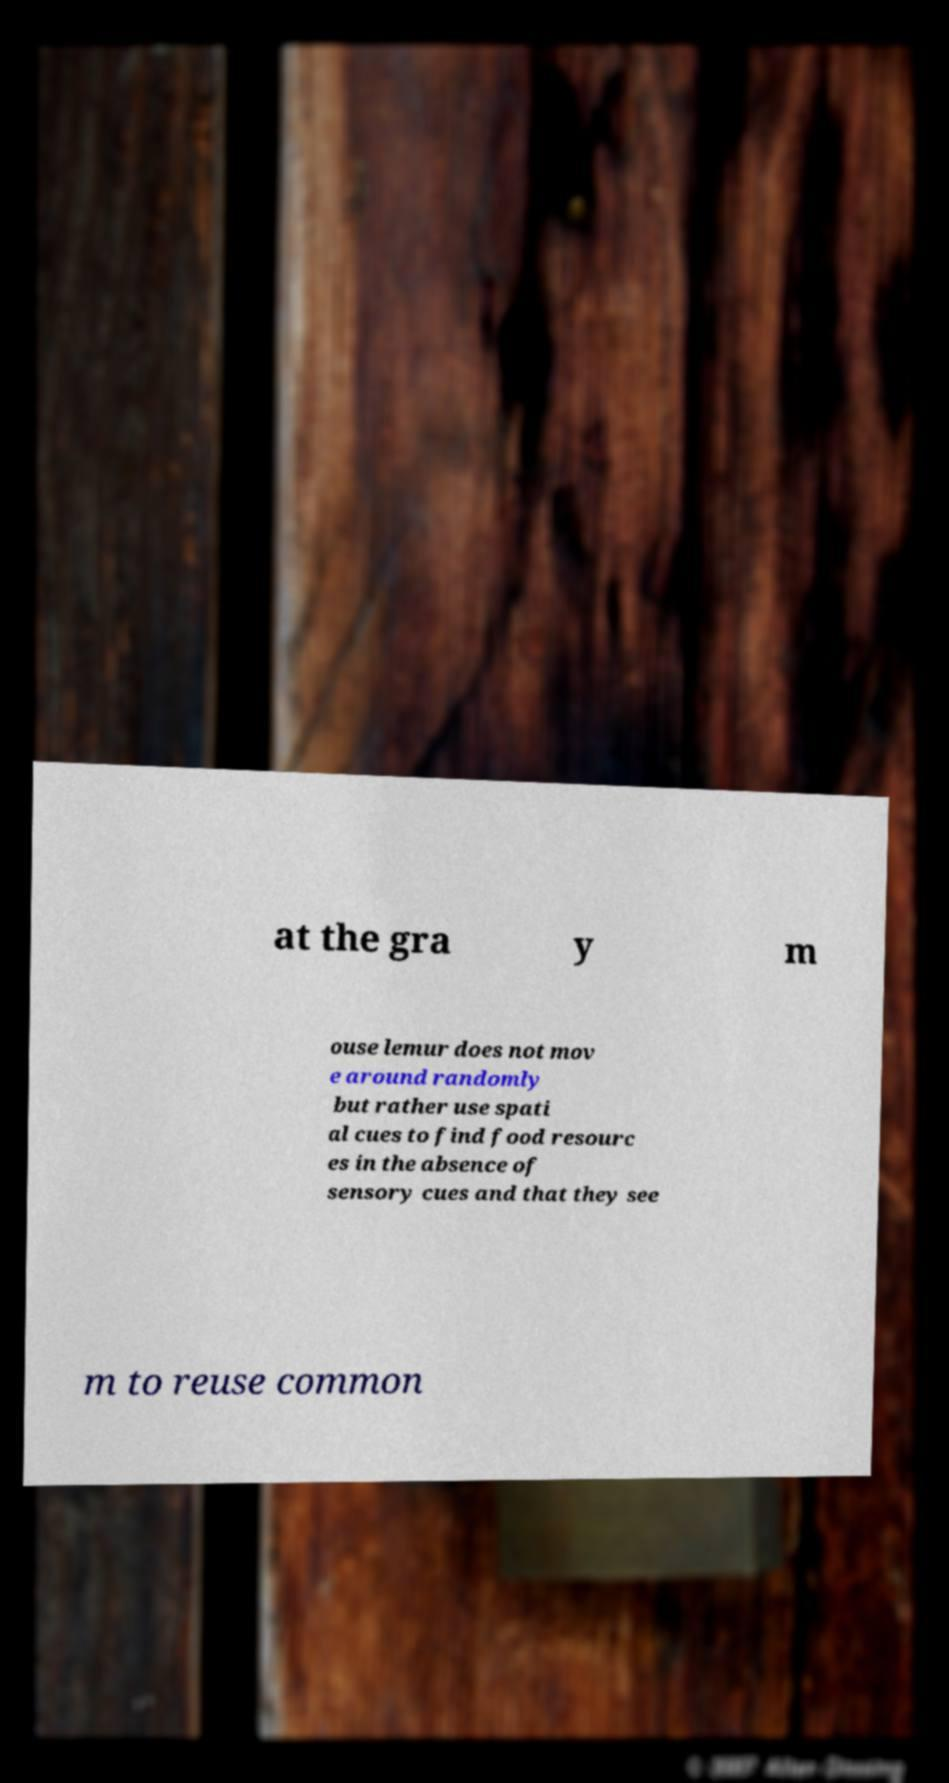Please identify and transcribe the text found in this image. at the gra y m ouse lemur does not mov e around randomly but rather use spati al cues to find food resourc es in the absence of sensory cues and that they see m to reuse common 